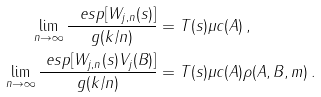Convert formula to latex. <formula><loc_0><loc_0><loc_500><loc_500>\lim _ { n \to \infty } \frac { \ e s p [ W _ { j , n } ( s ) ] } { g ( k / n ) } & = T ( s ) \mu c ( A ) \, , \\ \lim _ { n \to \infty } \frac { \ e s p [ W _ { j , n } ( s ) V _ { j } ( B ) ] } { g ( k / n ) } & = T ( s ) \mu c ( A ) \rho ( A , B , m ) \, .</formula> 